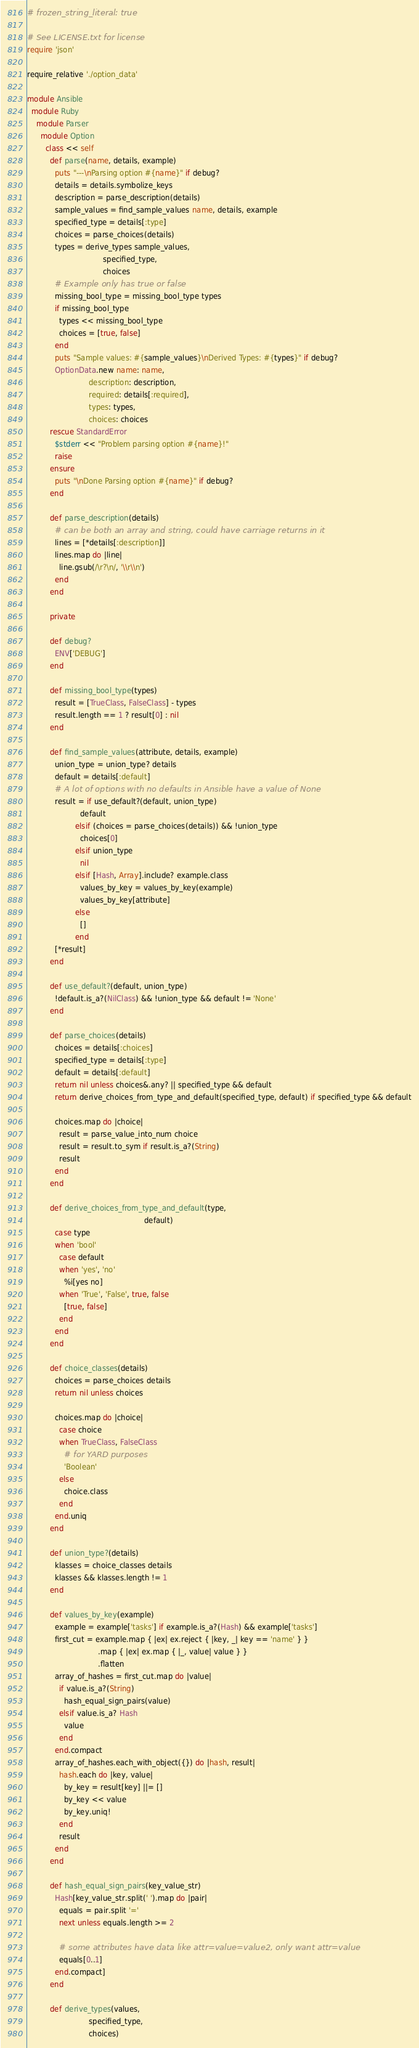Convert code to text. <code><loc_0><loc_0><loc_500><loc_500><_Ruby_># frozen_string_literal: true

# See LICENSE.txt for license
require 'json'

require_relative './option_data'

module Ansible
  module Ruby
    module Parser
      module Option
        class << self
          def parse(name, details, example)
            puts "---\nParsing option #{name}" if debug?
            details = details.symbolize_keys
            description = parse_description(details)
            sample_values = find_sample_values name, details, example
            specified_type = details[:type]
            choices = parse_choices(details)
            types = derive_types sample_values,
                                 specified_type,
                                 choices
            # Example only has true or false
            missing_bool_type = missing_bool_type types
            if missing_bool_type
              types << missing_bool_type
              choices = [true, false]
            end
            puts "Sample values: #{sample_values}\nDerived Types: #{types}" if debug?
            OptionData.new name: name,
                           description: description,
                           required: details[:required],
                           types: types,
                           choices: choices
          rescue StandardError
            $stderr << "Problem parsing option #{name}!"
            raise
          ensure
            puts "\nDone Parsing option #{name}" if debug?
          end

          def parse_description(details)
            # can be both an array and string, could have carriage returns in it
            lines = [*details[:description]]
            lines.map do |line|
              line.gsub(/\r?\n/, '\\r\\n')
            end
          end

          private

          def debug?
            ENV['DEBUG']
          end

          def missing_bool_type(types)
            result = [TrueClass, FalseClass] - types
            result.length == 1 ? result[0] : nil
          end

          def find_sample_values(attribute, details, example)
            union_type = union_type? details
            default = details[:default]
            # A lot of options with no defaults in Ansible have a value of None
            result = if use_default?(default, union_type)
                       default
                     elsif (choices = parse_choices(details)) && !union_type
                       choices[0]
                     elsif union_type
                       nil
                     elsif [Hash, Array].include? example.class
                       values_by_key = values_by_key(example)
                       values_by_key[attribute]
                     else
                       []
                     end
            [*result]
          end

          def use_default?(default, union_type)
            !default.is_a?(NilClass) && !union_type && default != 'None'
          end

          def parse_choices(details)
            choices = details[:choices]
            specified_type = details[:type]
            default = details[:default]
            return nil unless choices&.any? || specified_type && default
            return derive_choices_from_type_and_default(specified_type, default) if specified_type && default

            choices.map do |choice|
              result = parse_value_into_num choice
              result = result.to_sym if result.is_a?(String)
              result
            end
          end

          def derive_choices_from_type_and_default(type,
                                                   default)
            case type
            when 'bool'
              case default
              when 'yes', 'no'
                %i[yes no]
              when 'True', 'False', true, false
                [true, false]
              end
            end
          end

          def choice_classes(details)
            choices = parse_choices details
            return nil unless choices

            choices.map do |choice|
              case choice
              when TrueClass, FalseClass
                # for YARD purposes
                'Boolean'
              else
                choice.class
              end
            end.uniq
          end

          def union_type?(details)
            klasses = choice_classes details
            klasses && klasses.length != 1
          end

          def values_by_key(example)
            example = example['tasks'] if example.is_a?(Hash) && example['tasks']
            first_cut = example.map { |ex| ex.reject { |key, _| key == 'name' } }
                               .map { |ex| ex.map { |_, value| value } }
                               .flatten
            array_of_hashes = first_cut.map do |value|
              if value.is_a?(String)
                hash_equal_sign_pairs(value)
              elsif value.is_a? Hash
                value
              end
            end.compact
            array_of_hashes.each_with_object({}) do |hash, result|
              hash.each do |key, value|
                by_key = result[key] ||= []
                by_key << value
                by_key.uniq!
              end
              result
            end
          end

          def hash_equal_sign_pairs(key_value_str)
            Hash[key_value_str.split(' ').map do |pair|
              equals = pair.split '='
              next unless equals.length >= 2

              # some attributes have data like attr=value=value2, only want attr=value
              equals[0..1]
            end.compact]
          end

          def derive_types(values,
                           specified_type,
                           choices)</code> 